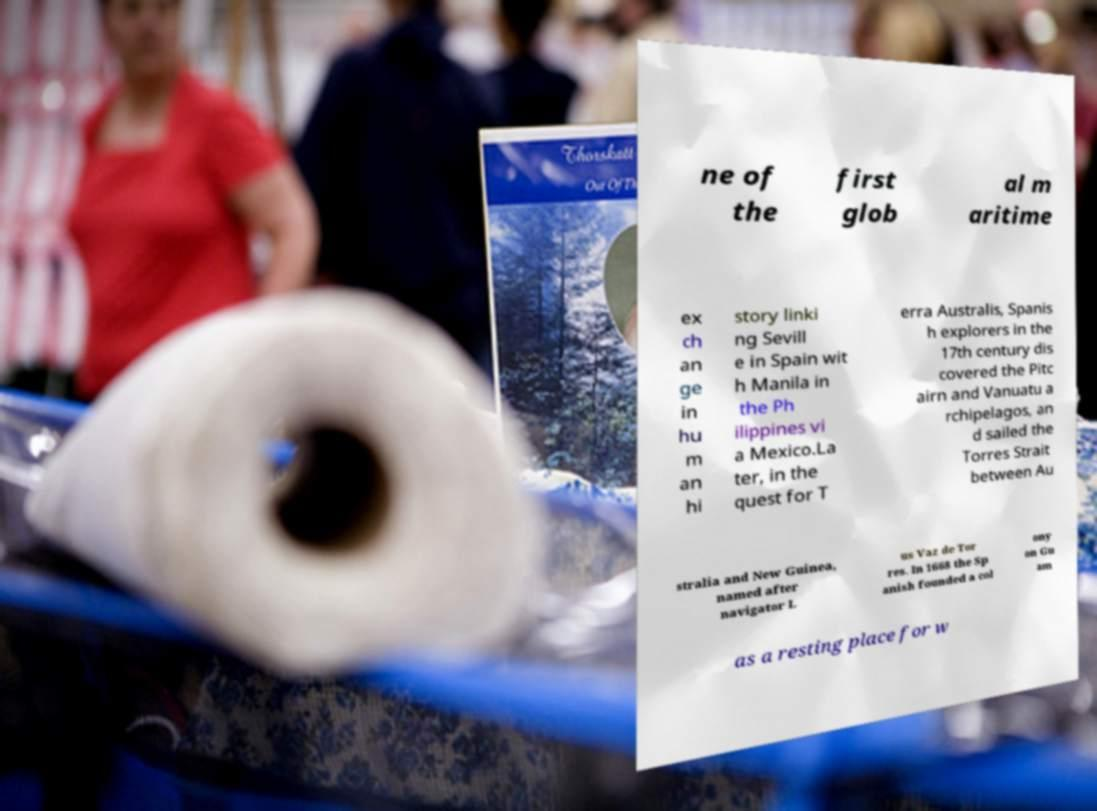For documentation purposes, I need the text within this image transcribed. Could you provide that? ne of the first glob al m aritime ex ch an ge in hu m an hi story linki ng Sevill e in Spain wit h Manila in the Ph ilippines vi a Mexico.La ter, in the quest for T erra Australis, Spanis h explorers in the 17th century dis covered the Pitc airn and Vanuatu a rchipelagos, an d sailed the Torres Strait between Au stralia and New Guinea, named after navigator L us Vaz de Tor res. In 1668 the Sp anish founded a col ony on Gu am as a resting place for w 